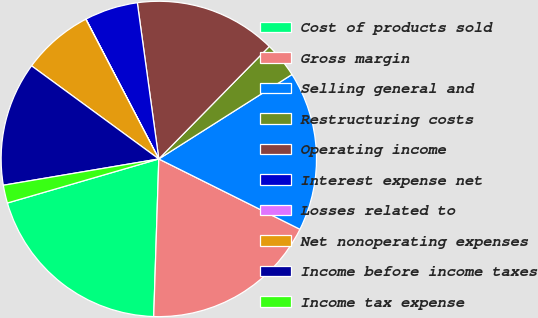Convert chart. <chart><loc_0><loc_0><loc_500><loc_500><pie_chart><fcel>Cost of products sold<fcel>Gross margin<fcel>Selling general and<fcel>Restructuring costs<fcel>Operating income<fcel>Interest expense net<fcel>Losses related to<fcel>Net nonoperating expenses<fcel>Income before income taxes<fcel>Income tax expense<nl><fcel>19.98%<fcel>18.16%<fcel>16.35%<fcel>3.65%<fcel>14.53%<fcel>5.47%<fcel>0.02%<fcel>7.28%<fcel>12.72%<fcel>1.84%<nl></chart> 